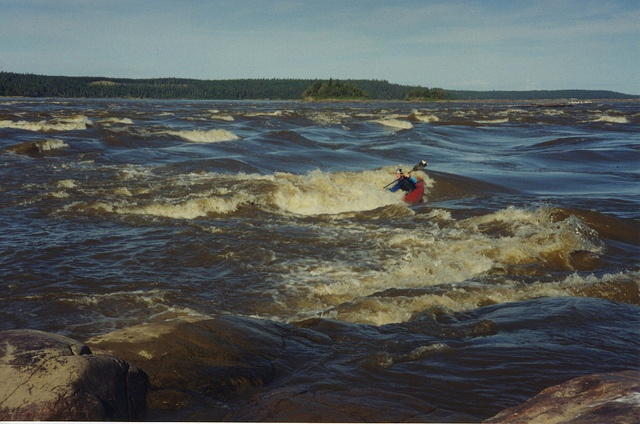Describe the objects in this image and their specific colors. I can see boat in gray, maroon, black, and tan tones and people in gray, black, navy, and tan tones in this image. 